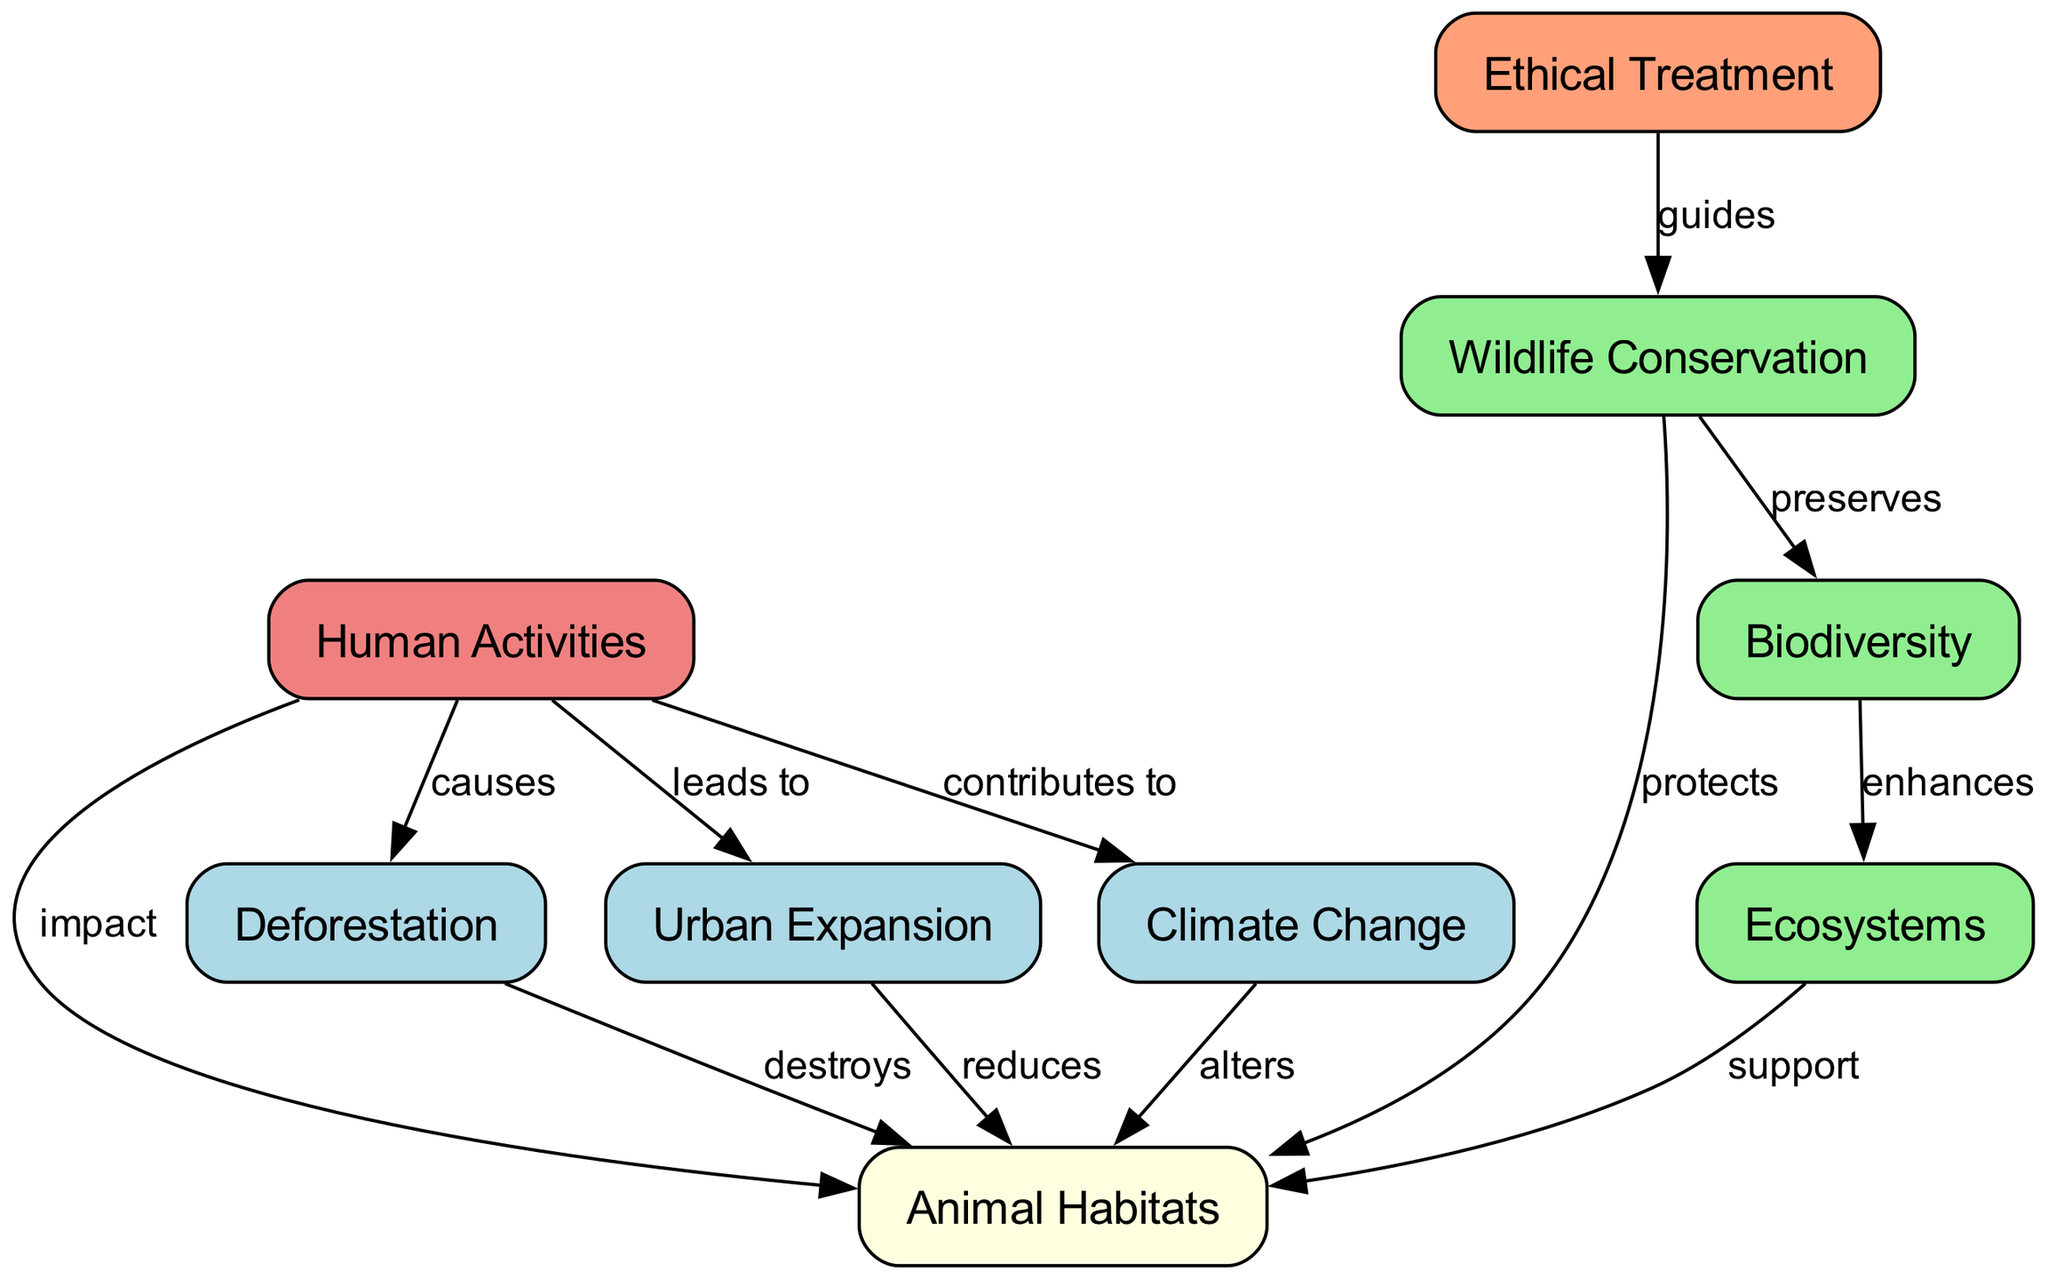What is the total number of nodes in the diagram? The diagram lists out distinct entities. Counting these nodes reveals that there are nine unique nodes labeled: Ecosystems, Animal Habitats, Human Activities, Deforestation, Urban Expansion, Climate Change, Wildlife Conservation, Ethical Treatment, and Biodiversity.
Answer: Nine What label describes the relationship between Human Activities and Animal Habitats? The diagram shows an edge connecting Human Activities and Animal Habitats with the label "impact." This label indicates the effect that human activities have on animal habitats.
Answer: Impact Which actions are indicated as causing damage to Animal Habitats? The relationship edges indicate Deforestation and Urban Expansion as the actions that destroy and reduce animal habitats, respectively. These are marked with the labels "destroys" and "reduces."
Answer: Deforestation, Urban Expansion What are the two main outcomes of Climate Change on Animal Habitats? The diagram specifies that Climate Change alters animal habitats. It does not specify other direct effects but implies that the changes are significant. Thus, the main outcome connected directly to Climate Change affecting animal habitats is indicated by the label "alters."
Answer: Alters How does Wildlife Conservation relate to Ethical Treatment? There is a directed edge from Ethical Treatment to Wildlife Conservation with the label "guides." This relationship highlights that ethical considerations influence the approach and actions taken in wildlife conservation efforts.
Answer: Guides Which node enhances Ecosystems? The directed edge from Biodiversity to Ecosystems is labeled "enhances." This indicates that biodiversity plays a role in improving or enriching ecosystems.
Answer: Biodiversity What is the relationship between Wildlife Conservation and Biodiversity? The diagram denotes that Wildlife Conservation preserves Biodiversity, indicating that conservation efforts are aimed at maintaining diverse species within ecosystems.
Answer: Preserves How do Human Activities contribute to Climate Change? Human Activities are noted to contribute to Climate Change directly in the diagram. The relationship reflects the ongoing influence of human actions on climate patterns.
Answer: Contributes Which two activities are indicated as leading to Urban Expansion? The diagram suggests that Human Activities lead to Urban Expansion. Although it doesn't specify particular activities, the label "leads to" refers generally to the consequences of various human actions on land use, leading to urban growth.
Answer: Human Activities 